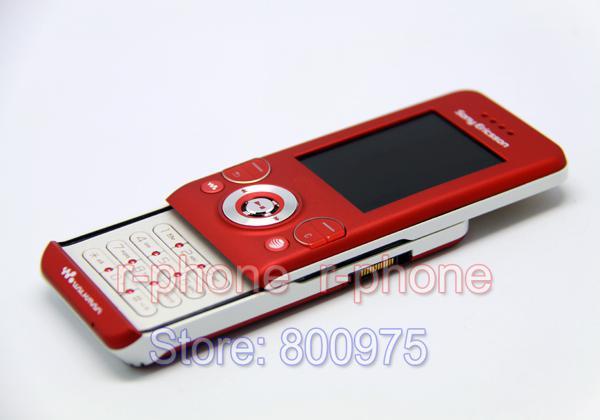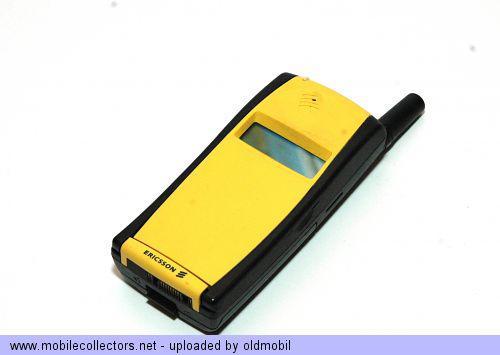The first image is the image on the left, the second image is the image on the right. For the images shown, is this caption "A yellow cellphone has a visible black antena in one of the images." true? Answer yes or no. Yes. The first image is the image on the left, the second image is the image on the right. Assess this claim about the two images: "One of the cell phones is yellow with a short black antenna.". Correct or not? Answer yes or no. Yes. 